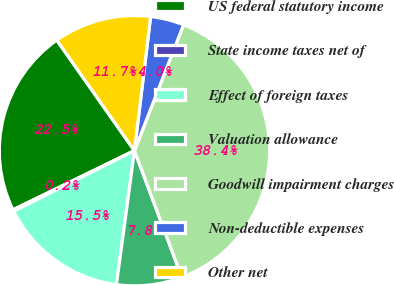<chart> <loc_0><loc_0><loc_500><loc_500><pie_chart><fcel>US federal statutory income<fcel>State income taxes net of<fcel>Effect of foreign taxes<fcel>Valuation allowance<fcel>Goodwill impairment charges<fcel>Non-deductible expenses<fcel>Other net<nl><fcel>22.46%<fcel>0.19%<fcel>15.47%<fcel>7.83%<fcel>38.38%<fcel>4.01%<fcel>11.65%<nl></chart> 